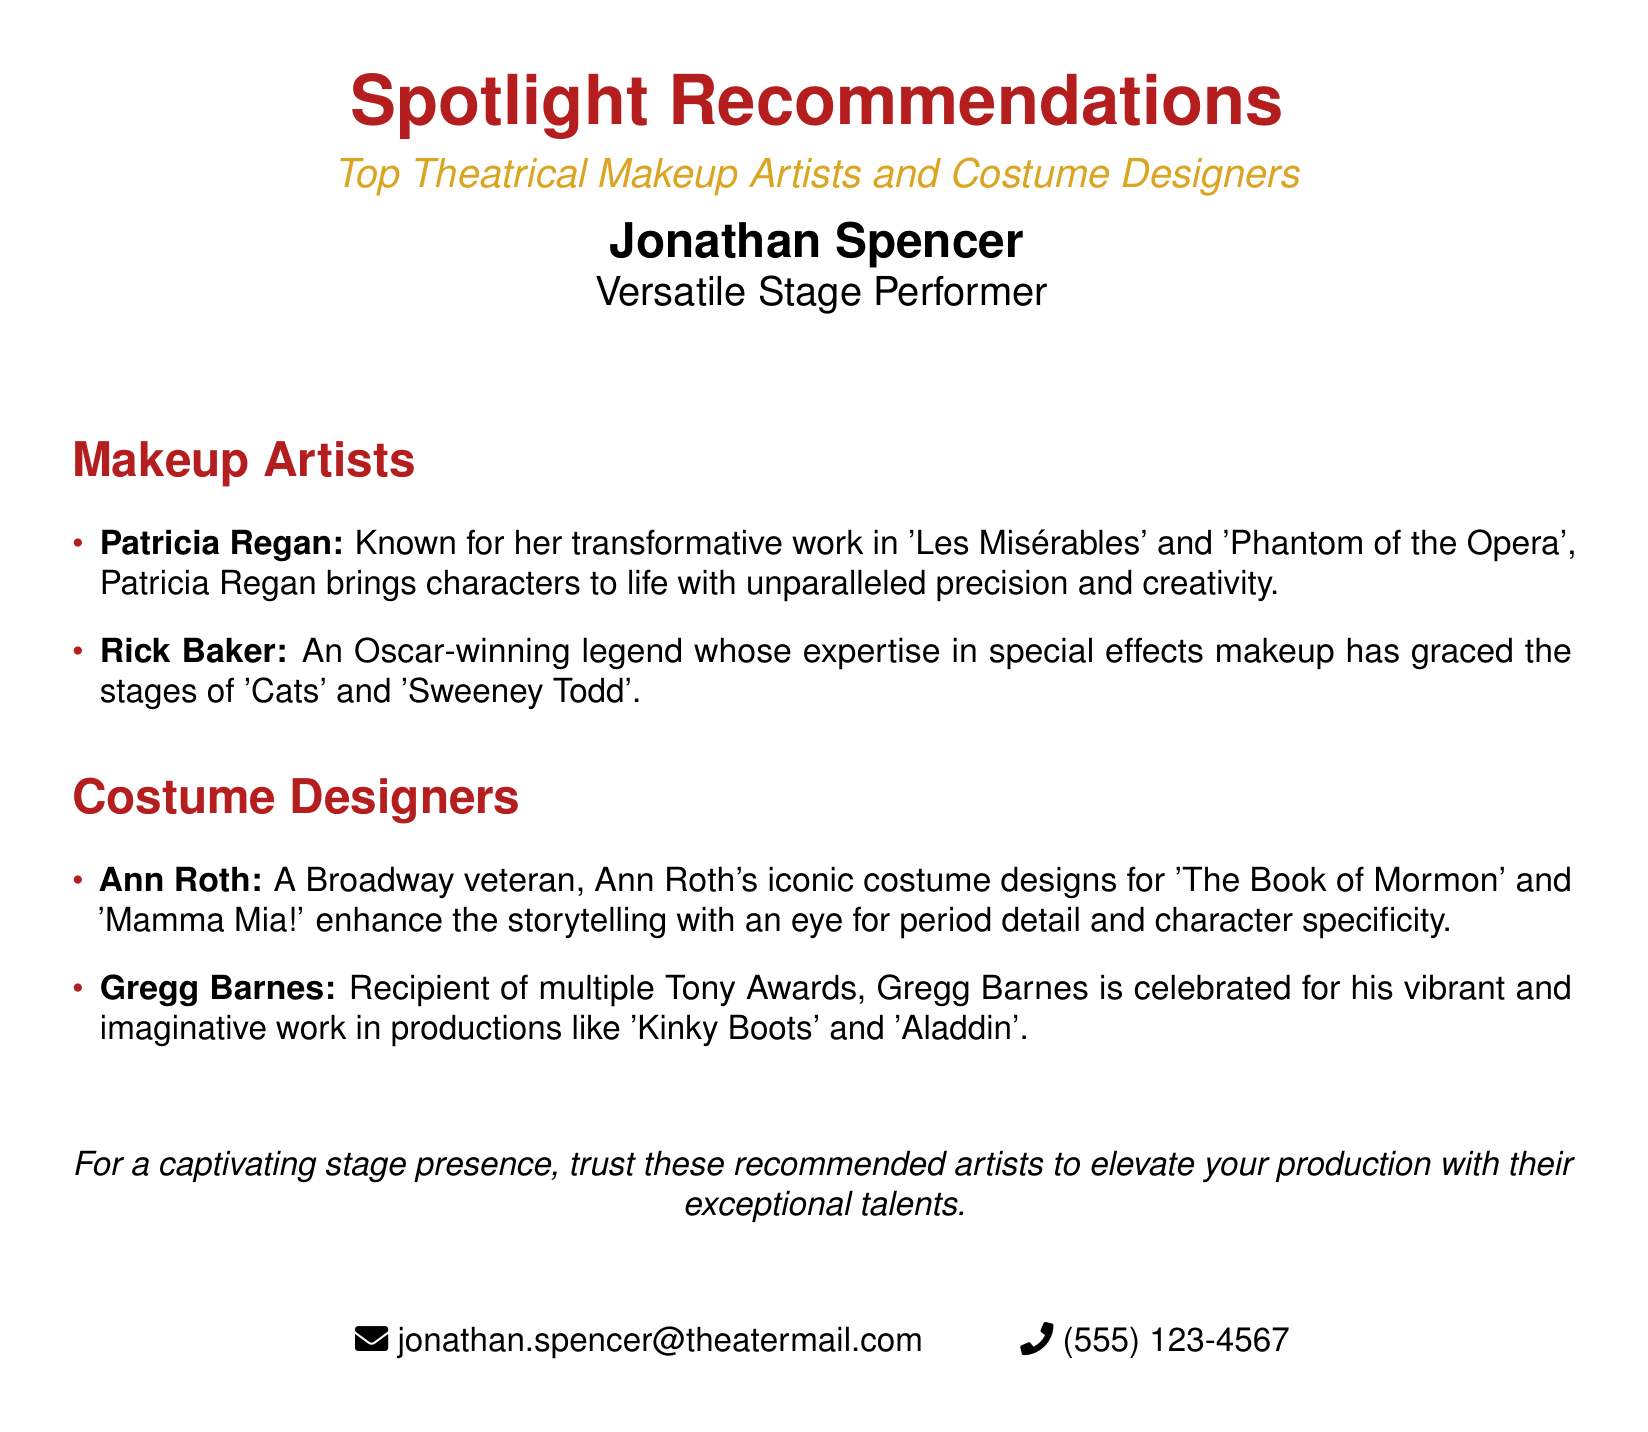What is the title of the document? The title of the document is displayed prominently at the top as "Spotlight Recommendations".
Answer: Spotlight Recommendations Who is listed as the versatile stage performer? The document identifies Jonathan Spencer as the versatile stage performer.
Answer: Jonathan Spencer What makeup artist is known for her work in 'Les Misérables'? The document notes that Patricia Regan is recognized for her work in 'Les Misérables'.
Answer: Patricia Regan How many Tony Awards has Gregg Barnes received? The document states that Gregg Barnes is a recipient of multiple Tony Awards, implying he has received more than one.
Answer: Multiple Which costume designer is associated with 'The Book of Mormon'? The document mentions Ann Roth in connection with 'The Book of Mormon'.
Answer: Ann Roth What is the email address provided in the document? The email address for Jonathan Spencer is specified in the contact section at the bottom.
Answer: jonathan.spencer@theatermail.com What type of artists are spotlighted in the recommendations? The document highlights makeup artists and costume designers in its recommendations.
Answer: Makeup artists and costume designers What is the contact phone number listed? The phone number for Jonathan Spencer is provided in the contact section of the document.
Answer: (555) 123-4567 